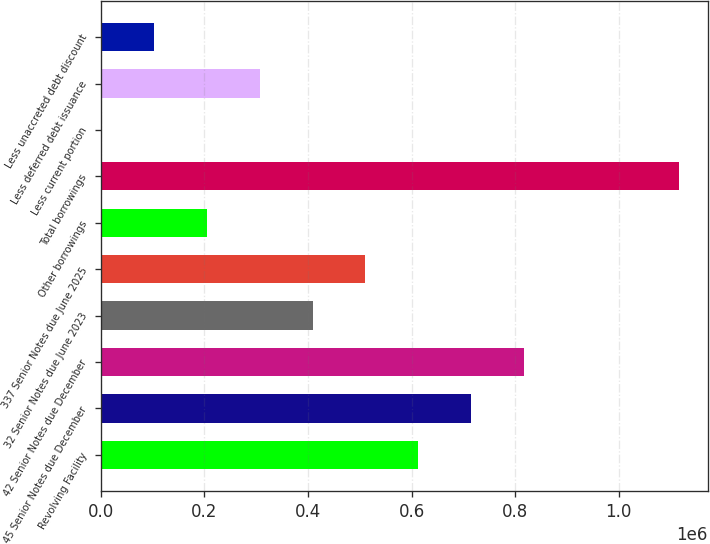Convert chart. <chart><loc_0><loc_0><loc_500><loc_500><bar_chart><fcel>Revolving Facility<fcel>45 Senior Notes due December<fcel>42 Senior Notes due December<fcel>32 Senior Notes due June 2023<fcel>337 Senior Notes due June 2025<fcel>Other borrowings<fcel>Total borrowings<fcel>Less current portion<fcel>Less deferred debt issuance<fcel>Less unaccreted debt discount<nl><fcel>612942<fcel>714925<fcel>816908<fcel>408977<fcel>510960<fcel>205011<fcel>1.11622e+06<fcel>1046<fcel>306994<fcel>103029<nl></chart> 